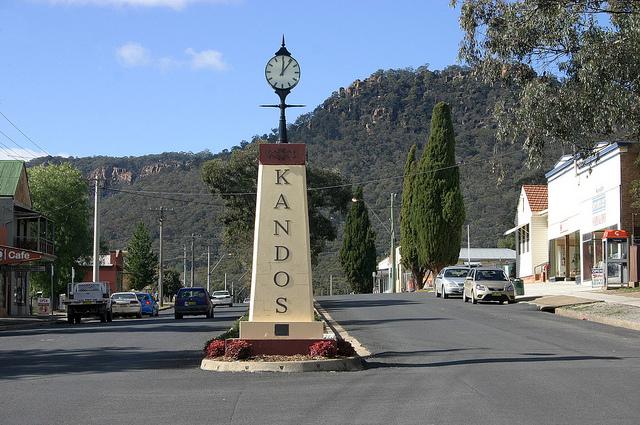What is the name of the city?
Be succinct. Kandos. What time is it?
Concise answer only. 12:05. How tall is the clock tower?
Short answer required. 20 feet. What does the statue say?
Short answer required. Kandos. 